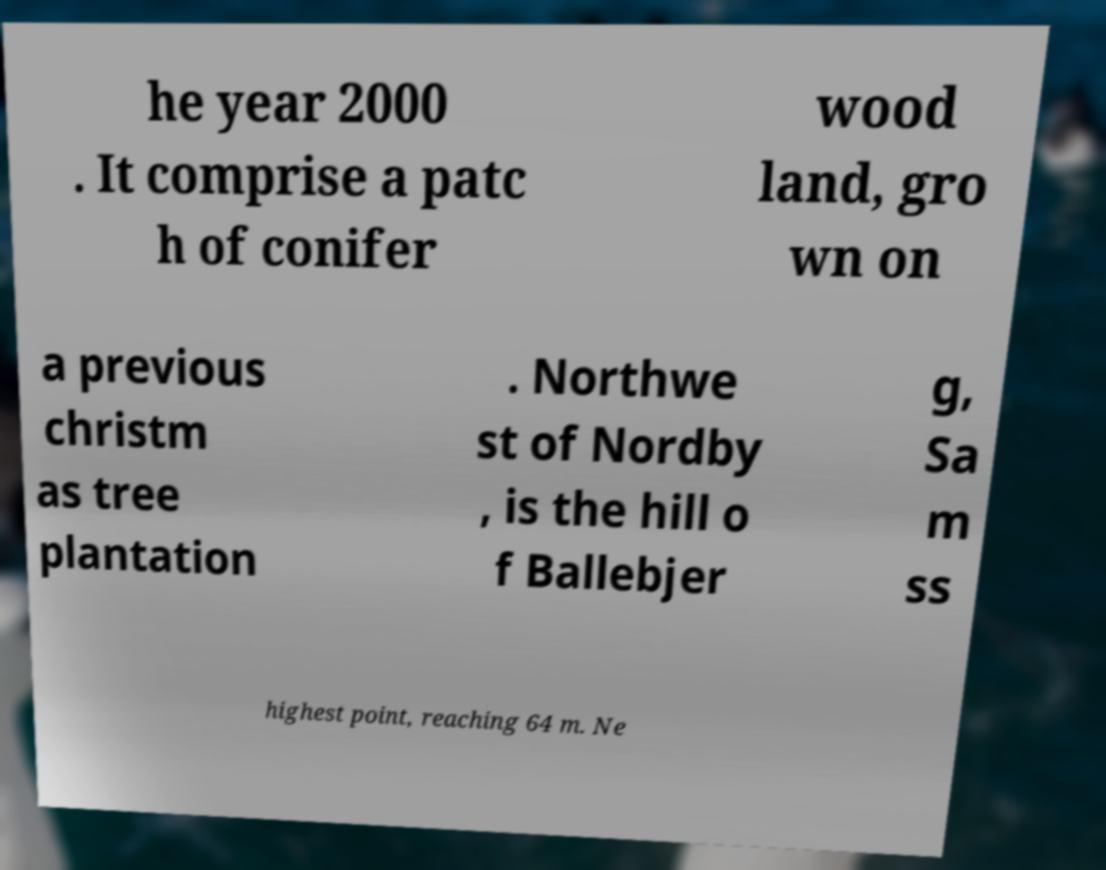What messages or text are displayed in this image? I need them in a readable, typed format. he year 2000 . It comprise a patc h of conifer wood land, gro wn on a previous christm as tree plantation . Northwe st of Nordby , is the hill o f Ballebjer g, Sa m ss highest point, reaching 64 m. Ne 